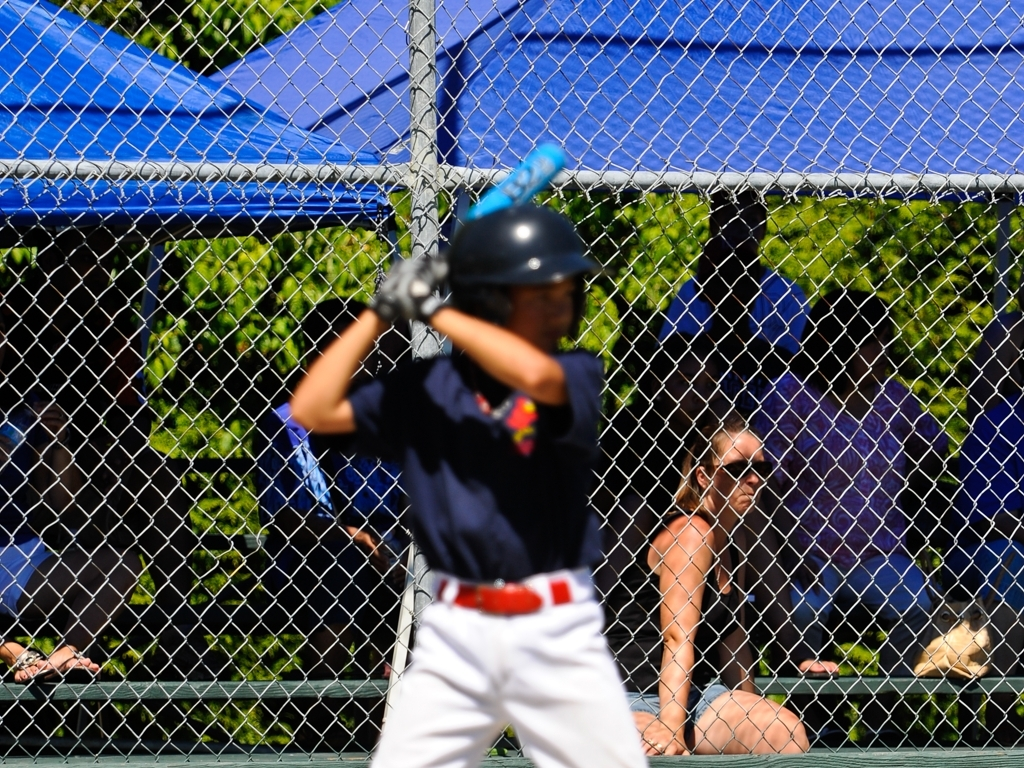Can you guess at what moment during the game this shot was taken? This shot was likely taken moments before the pitcher throws the ball, as the batter appears to be in the stance of anticipation, preparing for the pitch. Does anything in the image indicate how the game is progressing? Without additional context like the scoreboard or visible gameplay action, it's not possible to infer the progress of the game from this single still image. However, the focus and readiness of the batter might suggest a critical point in the game where the outcome of the pitch could be significant. 